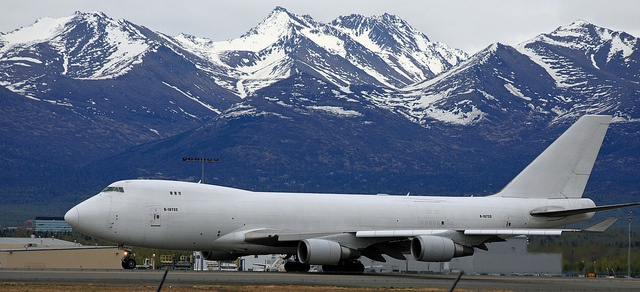Describe the objects in this image and their specific colors. I can see a airplane in lightgray, darkgray, black, and gray tones in this image. 